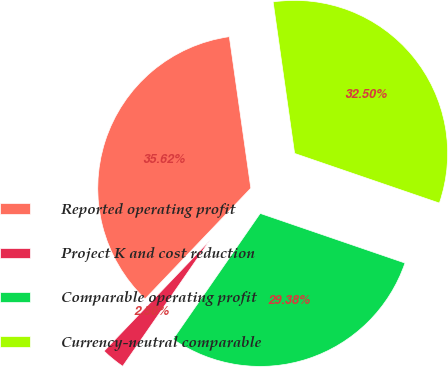Convert chart. <chart><loc_0><loc_0><loc_500><loc_500><pie_chart><fcel>Reported operating profit<fcel>Project K and cost reduction<fcel>Comparable operating profit<fcel>Currency-neutral comparable<nl><fcel>35.62%<fcel>2.5%<fcel>29.38%<fcel>32.5%<nl></chart> 